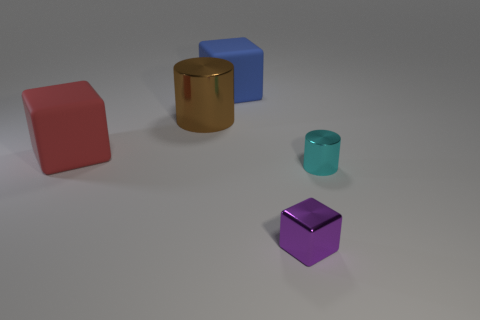Add 4 large purple matte things. How many objects exist? 9 Subtract all cylinders. How many objects are left? 3 Subtract 1 brown cylinders. How many objects are left? 4 Subtract all small cyan metallic cylinders. Subtract all large green rubber cubes. How many objects are left? 4 Add 3 big objects. How many big objects are left? 6 Add 2 tiny red rubber balls. How many tiny red rubber balls exist? 2 